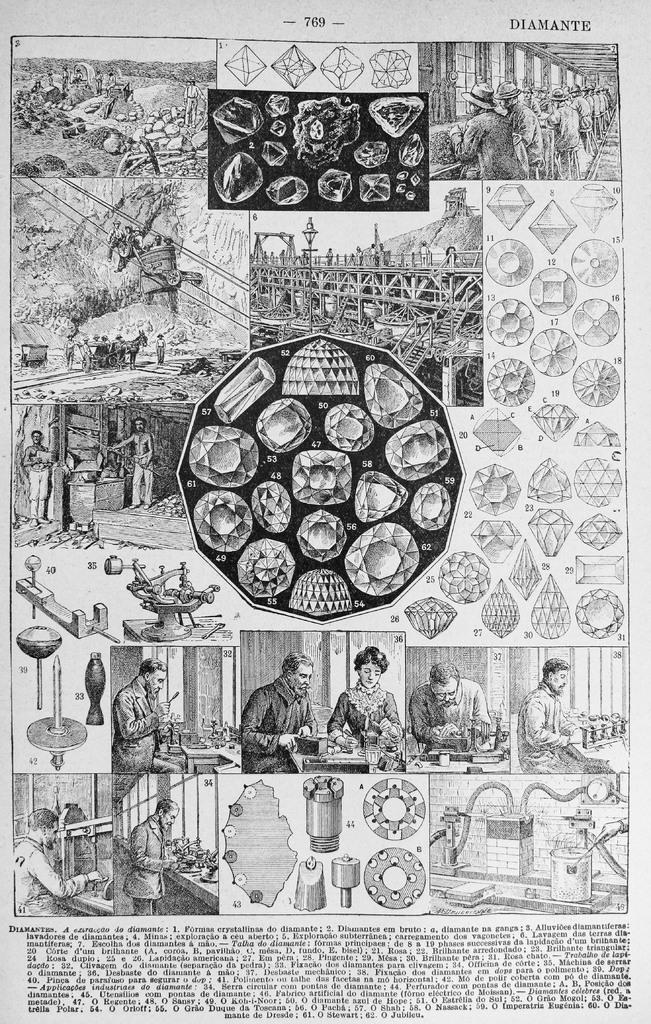What is present in the image that contains information or a message? There is a poster in the image that contains information or a message. What can be found on the poster besides the text? The poster contains images in addition to the text. What type of farm animals can be seen grazing on the road in the image? There is no farm or road present in the image; it only contains a poster with text and images. 